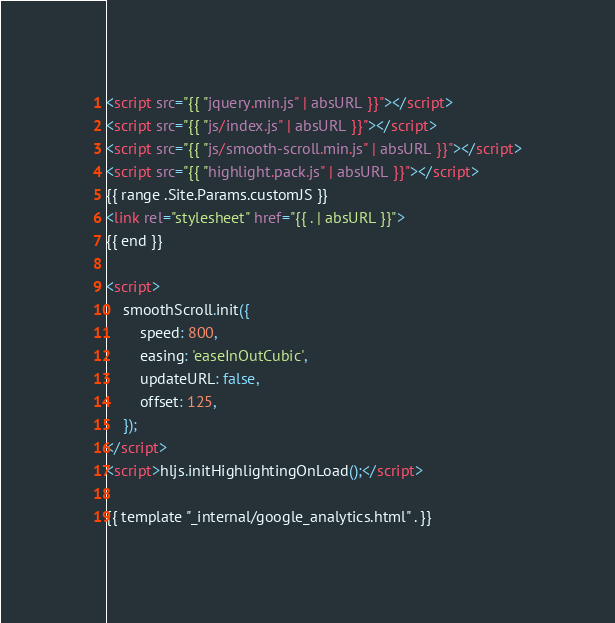<code> <loc_0><loc_0><loc_500><loc_500><_HTML_><script src="{{ "jquery.min.js" | absURL }}"></script>
<script src="{{ "js/index.js" | absURL }}"></script>
<script src="{{ "js/smooth-scroll.min.js" | absURL }}"></script>
<script src="{{ "highlight.pack.js" | absURL }}"></script>
{{ range .Site.Params.customJS }}
<link rel="stylesheet" href="{{ . | absURL }}">
{{ end }}

<script>
    smoothScroll.init({
        speed: 800,
        easing: 'easeInOutCubic',
        updateURL: false,
        offset: 125,
    });
</script>
<script>hljs.initHighlightingOnLoad();</script>

{{ template "_internal/google_analytics.html" . }}</code> 